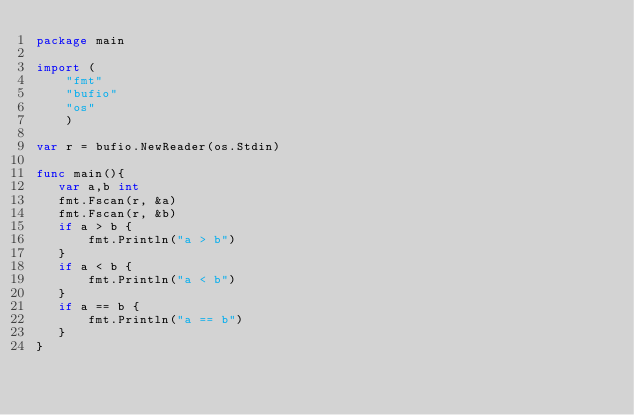Convert code to text. <code><loc_0><loc_0><loc_500><loc_500><_Go_>package main

import (
    "fmt"
    "bufio"
    "os"
    )
    
var r = bufio.NewReader(os.Stdin)

func main(){
   var a,b int 
   fmt.Fscan(r, &a)
   fmt.Fscan(r, &b)
   if a > b {
       fmt.Println("a > b")
   }
   if a < b {
       fmt.Println("a < b")
   }
   if a == b {
       fmt.Println("a == b")
   }
}
</code> 